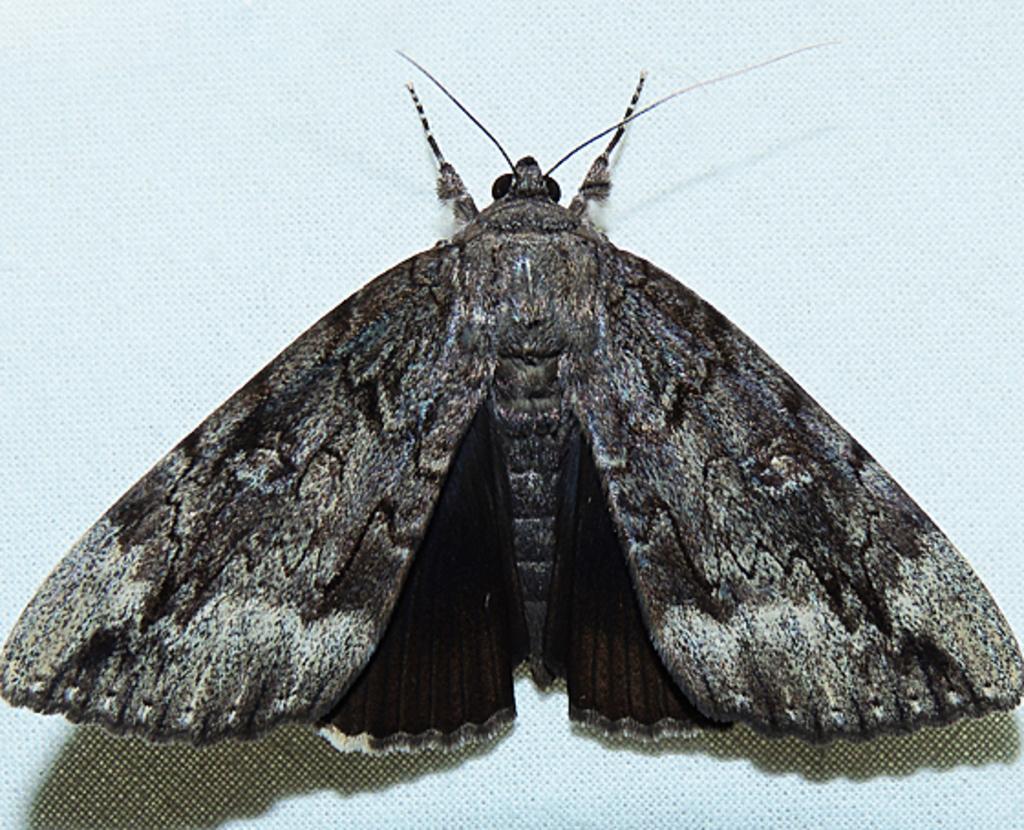Describe this image in one or two sentences. In the middle of this image, there is butterfly in black and white color combination, having wings and legs on a surface. And the background is white in color. 